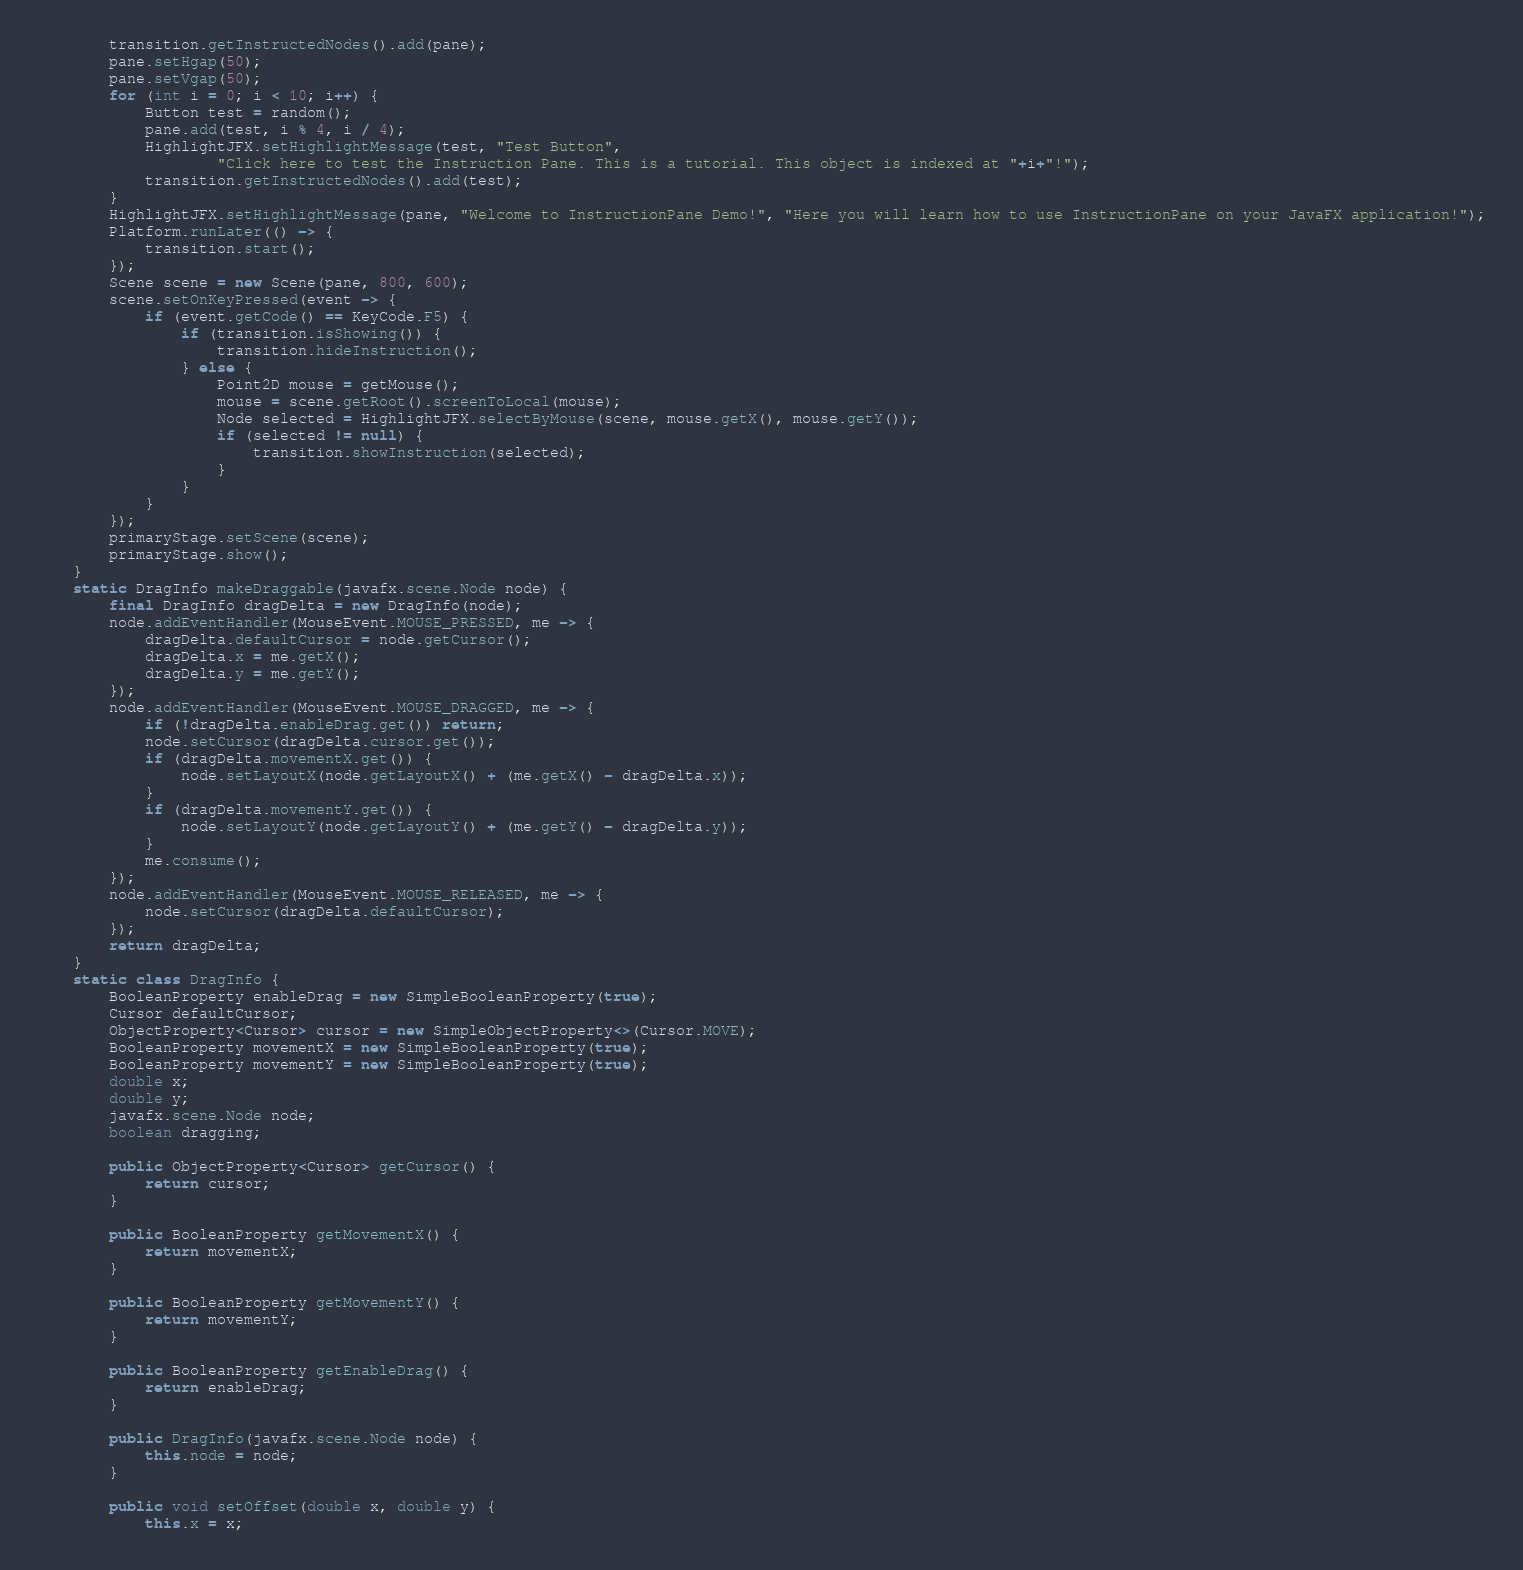<code> <loc_0><loc_0><loc_500><loc_500><_Java_>        transition.getInstructedNodes().add(pane);
        pane.setHgap(50);
        pane.setVgap(50);
        for (int i = 0; i < 10; i++) {
            Button test = random();
            pane.add(test, i % 4, i / 4);
            HighlightJFX.setHighlightMessage(test, "Test Button",
                    "Click here to test the Instruction Pane. This is a tutorial. This object is indexed at "+i+"!");
            transition.getInstructedNodes().add(test);
        }
        HighlightJFX.setHighlightMessage(pane, "Welcome to InstructionPane Demo!", "Here you will learn how to use InstructionPane on your JavaFX application!");
        Platform.runLater(() -> {
            transition.start();
        });
        Scene scene = new Scene(pane, 800, 600);
        scene.setOnKeyPressed(event -> {
            if (event.getCode() == KeyCode.F5) {
                if (transition.isShowing()) {
                    transition.hideInstruction();
                } else {
                    Point2D mouse = getMouse();
                    mouse = scene.getRoot().screenToLocal(mouse);
                    Node selected = HighlightJFX.selectByMouse(scene, mouse.getX(), mouse.getY());
                    if (selected != null) {
                        transition.showInstruction(selected);
                    }
                }
            }
        });
        primaryStage.setScene(scene);
        primaryStage.show();
    }
    static DragInfo makeDraggable(javafx.scene.Node node) {
        final DragInfo dragDelta = new DragInfo(node);
        node.addEventHandler(MouseEvent.MOUSE_PRESSED, me -> {
            dragDelta.defaultCursor = node.getCursor();
            dragDelta.x = me.getX();
            dragDelta.y = me.getY();
        });
        node.addEventHandler(MouseEvent.MOUSE_DRAGGED, me -> {
            if (!dragDelta.enableDrag.get()) return;
            node.setCursor(dragDelta.cursor.get());
            if (dragDelta.movementX.get()) {
                node.setLayoutX(node.getLayoutX() + (me.getX() - dragDelta.x));
            }
            if (dragDelta.movementY.get()) {
                node.setLayoutY(node.getLayoutY() + (me.getY() - dragDelta.y));
            }
            me.consume();
        });
        node.addEventHandler(MouseEvent.MOUSE_RELEASED, me -> {
            node.setCursor(dragDelta.defaultCursor);
        });
        return dragDelta;
    }
    static class DragInfo {
        BooleanProperty enableDrag = new SimpleBooleanProperty(true);
        Cursor defaultCursor;
        ObjectProperty<Cursor> cursor = new SimpleObjectProperty<>(Cursor.MOVE);
        BooleanProperty movementX = new SimpleBooleanProperty(true);
        BooleanProperty movementY = new SimpleBooleanProperty(true);
        double x;
        double y;
        javafx.scene.Node node;
        boolean dragging;

        public ObjectProperty<Cursor> getCursor() {
            return cursor;
        }

        public BooleanProperty getMovementX() {
            return movementX;
        }

        public BooleanProperty getMovementY() {
            return movementY;
        }

        public BooleanProperty getEnableDrag() {
            return enableDrag;
        }

        public DragInfo(javafx.scene.Node node) {
            this.node = node;
        }

        public void setOffset(double x, double y) {
            this.x = x;</code> 